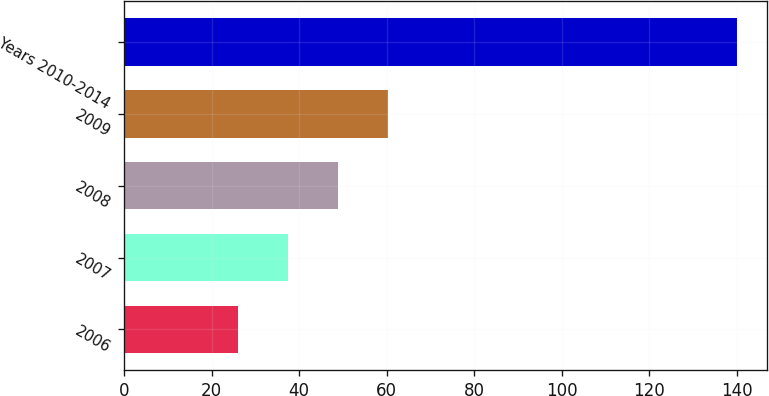Convert chart to OTSL. <chart><loc_0><loc_0><loc_500><loc_500><bar_chart><fcel>2006<fcel>2007<fcel>2008<fcel>2009<fcel>Years 2010-2014<nl><fcel>26<fcel>37.4<fcel>48.8<fcel>60.2<fcel>140<nl></chart> 